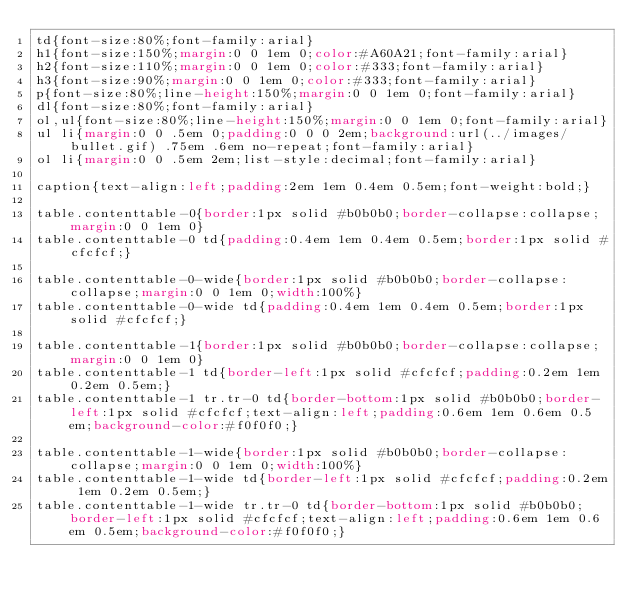<code> <loc_0><loc_0><loc_500><loc_500><_CSS_>td{font-size:80%;font-family:arial}
h1{font-size:150%;margin:0 0 1em 0;color:#A60A21;font-family:arial}
h2{font-size:110%;margin:0 0 1em 0;color:#333;font-family:arial}
h3{font-size:90%;margin:0 0 1em 0;color:#333;font-family:arial}
p{font-size:80%;line-height:150%;margin:0 0 1em 0;font-family:arial}
dl{font-size:80%;font-family:arial}
ol,ul{font-size:80%;line-height:150%;margin:0 0 1em 0;font-family:arial}
ul li{margin:0 0 .5em 0;padding:0 0 0 2em;background:url(../images/bullet.gif) .75em .6em no-repeat;font-family:arial}
ol li{margin:0 0 .5em 2em;list-style:decimal;font-family:arial}

caption{text-align:left;padding:2em 1em 0.4em 0.5em;font-weight:bold;}

table.contenttable-0{border:1px solid #b0b0b0;border-collapse:collapse;margin:0 0 1em 0}
table.contenttable-0 td{padding:0.4em 1em 0.4em 0.5em;border:1px solid #cfcfcf;}

table.contenttable-0-wide{border:1px solid #b0b0b0;border-collapse:collapse;margin:0 0 1em 0;width:100%}
table.contenttable-0-wide td{padding:0.4em 1em 0.4em 0.5em;border:1px solid #cfcfcf;}

table.contenttable-1{border:1px solid #b0b0b0;border-collapse:collapse;margin:0 0 1em 0}
table.contenttable-1 td{border-left:1px solid #cfcfcf;padding:0.2em 1em 0.2em 0.5em;}
table.contenttable-1 tr.tr-0 td{border-bottom:1px solid #b0b0b0;border-left:1px solid #cfcfcf;text-align:left;padding:0.6em 1em 0.6em 0.5em;background-color:#f0f0f0;}

table.contenttable-1-wide{border:1px solid #b0b0b0;border-collapse:collapse;margin:0 0 1em 0;width:100%}
table.contenttable-1-wide td{border-left:1px solid #cfcfcf;padding:0.2em 1em 0.2em 0.5em;}
table.contenttable-1-wide tr.tr-0 td{border-bottom:1px solid #b0b0b0;border-left:1px solid #cfcfcf;text-align:left;padding:0.6em 1em 0.6em 0.5em;background-color:#f0f0f0;}
</code> 